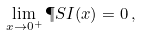<formula> <loc_0><loc_0><loc_500><loc_500>\lim _ { x \rightarrow 0 ^ { + } } \P S I ( x ) = 0 \, ,</formula> 